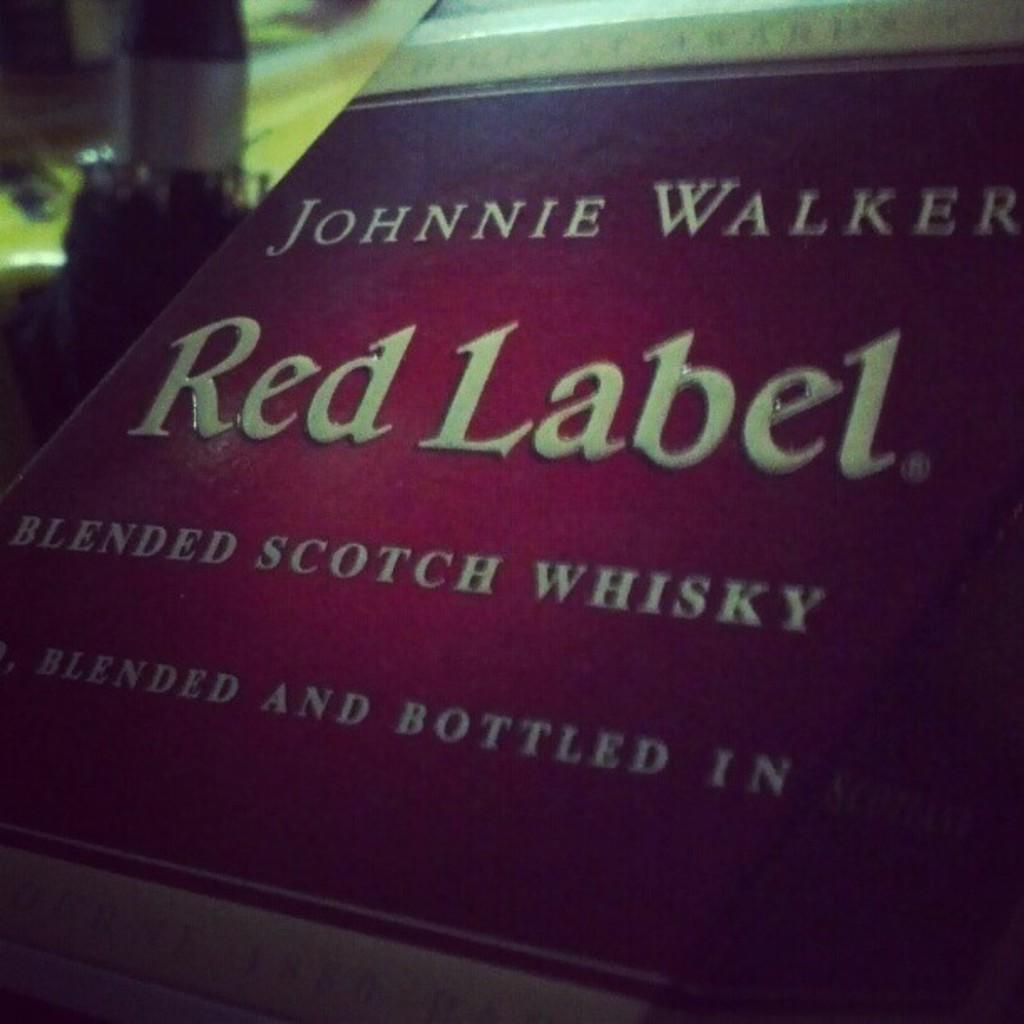<image>
Share a concise interpretation of the image provided. A box of Johnnie Walker Red Label whisky has a dark red label. 